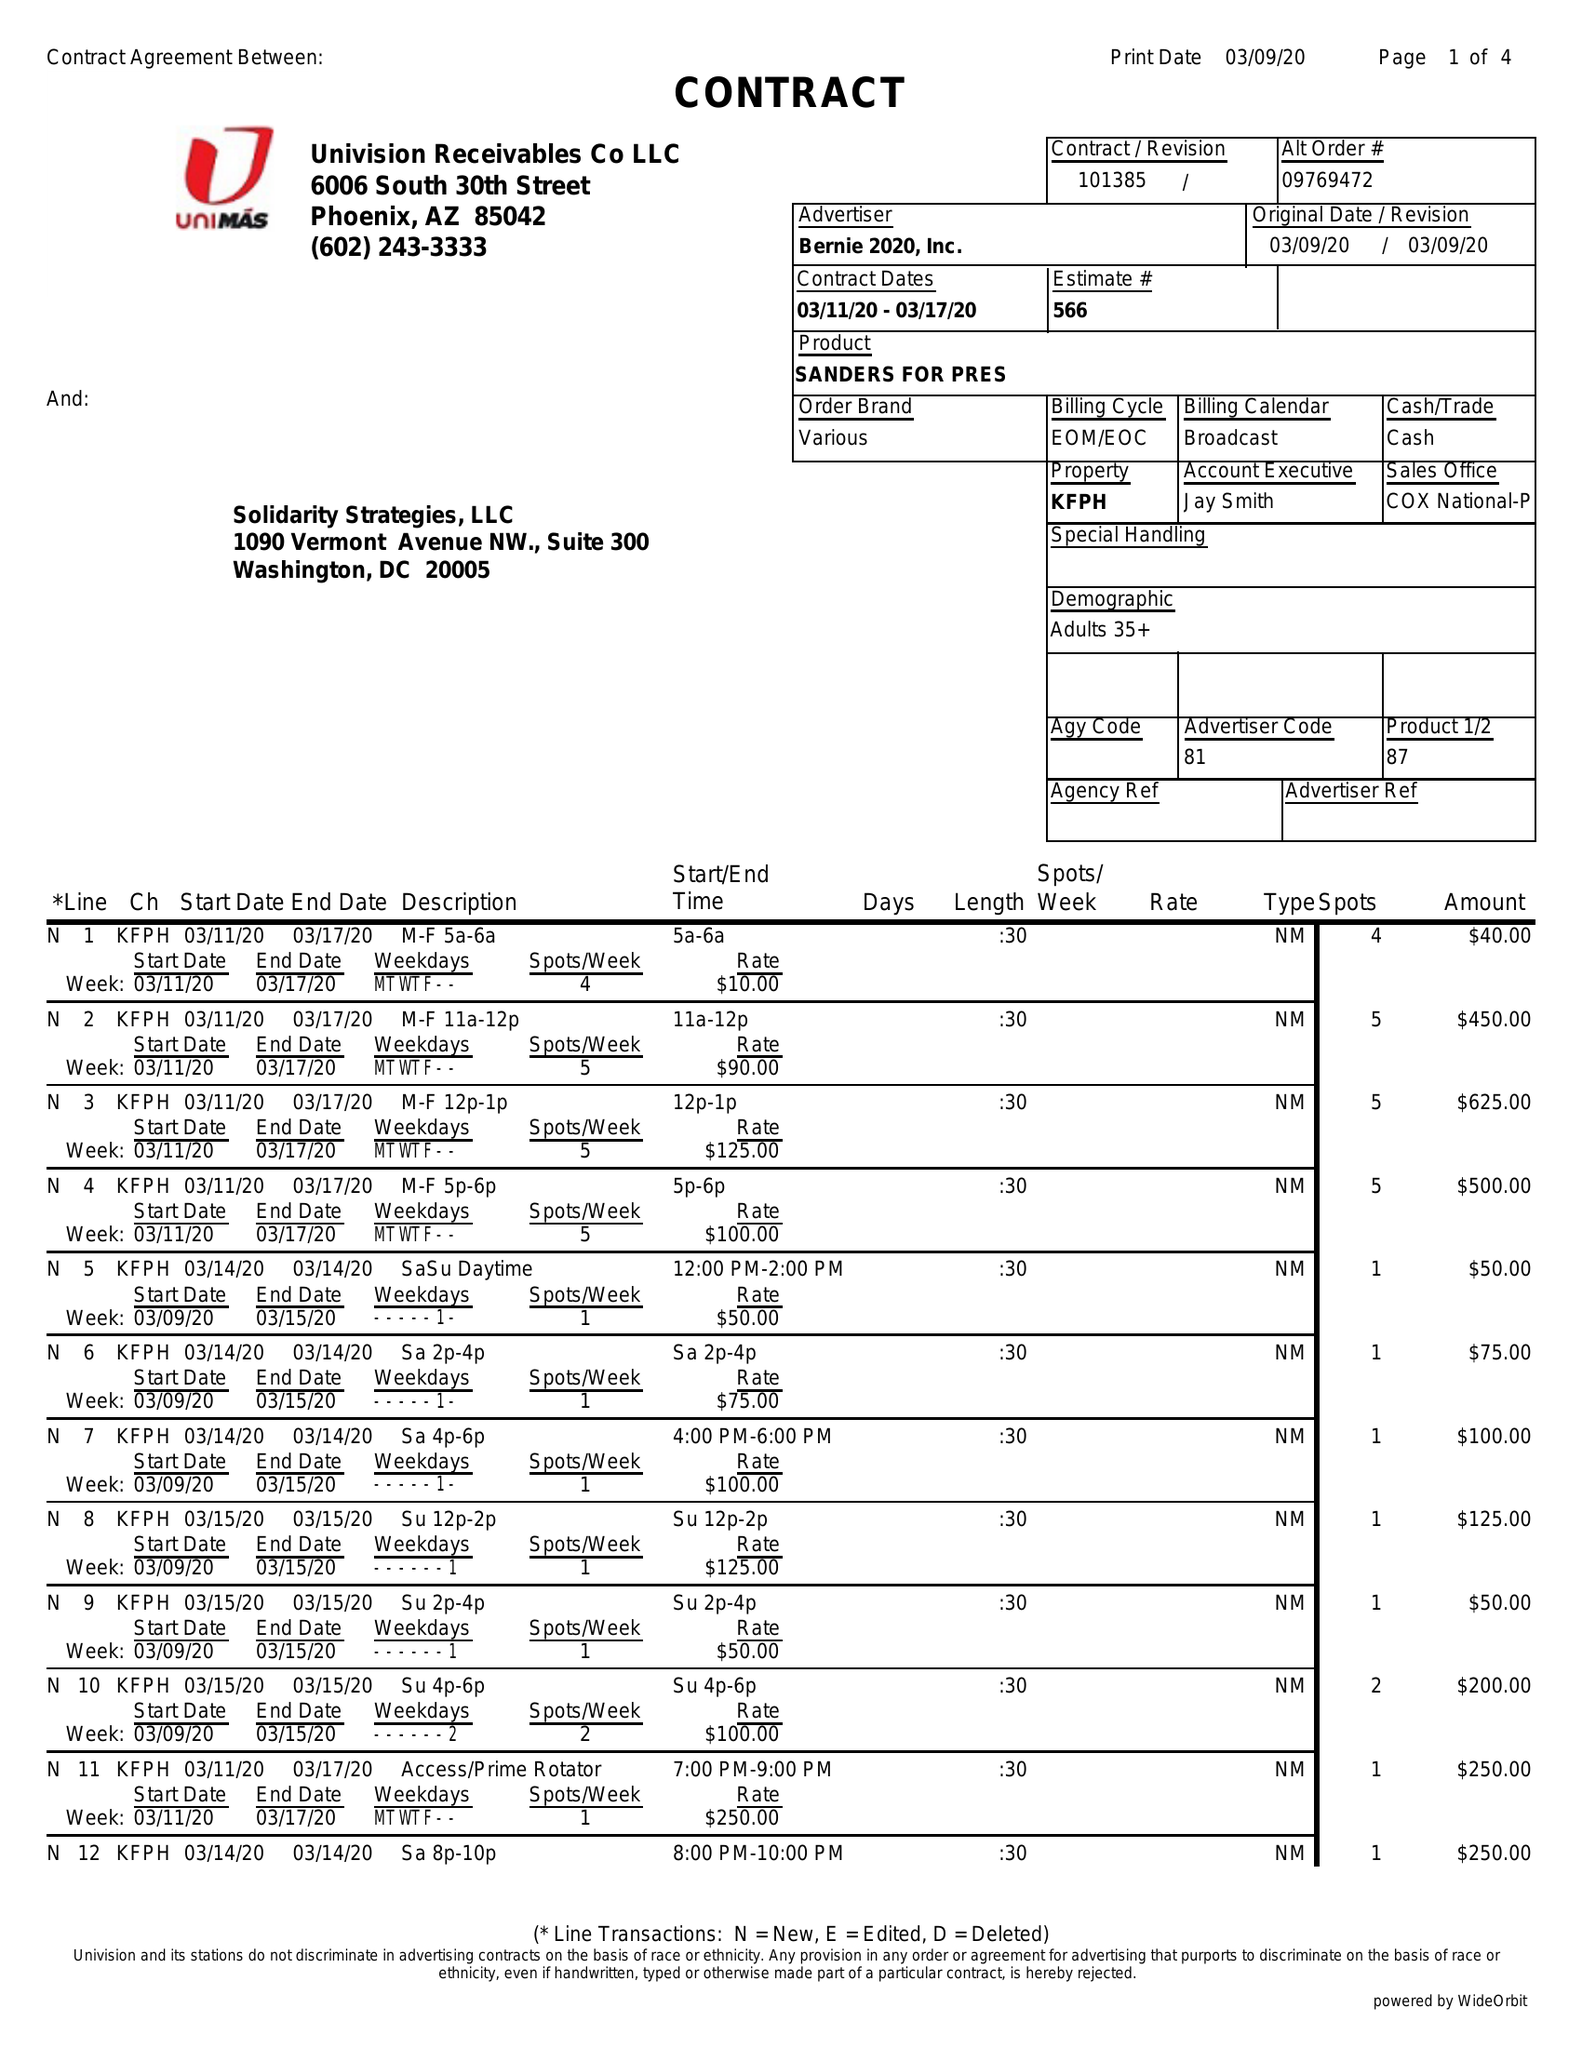What is the value for the advertiser?
Answer the question using a single word or phrase. BERNIE 2020, INC. 